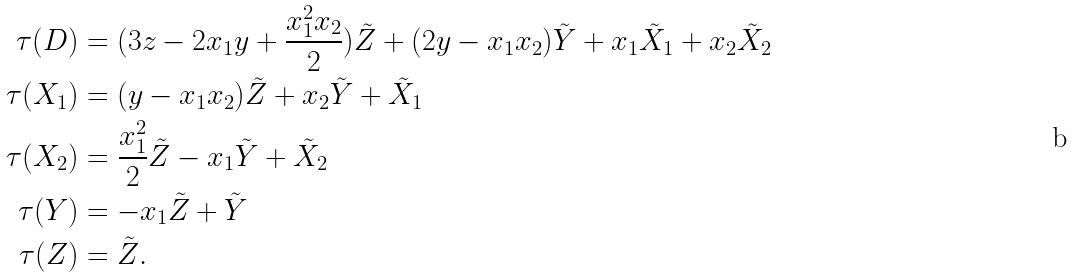Convert formula to latex. <formula><loc_0><loc_0><loc_500><loc_500>\tau ( D ) & = ( 3 z - 2 x _ { 1 } y + \frac { x _ { 1 } ^ { 2 } x _ { 2 } } { 2 } ) \tilde { Z } + ( 2 y - x _ { 1 } x _ { 2 } ) \tilde { Y } + x _ { 1 } \tilde { X } _ { 1 } + x _ { 2 } \tilde { X } _ { 2 } \\ \tau ( X _ { 1 } ) & = ( y - x _ { 1 } x _ { 2 } ) \tilde { Z } + x _ { 2 } \tilde { Y } + \tilde { X } _ { 1 } \\ \tau ( X _ { 2 } ) & = \frac { x _ { 1 } ^ { 2 } } { 2 } \tilde { Z } - x _ { 1 } \tilde { Y } + \tilde { X } _ { 2 } \\ \tau ( Y ) & = - x _ { 1 } \tilde { Z } + \tilde { Y } \\ \tau ( Z ) & = \tilde { Z } .</formula> 